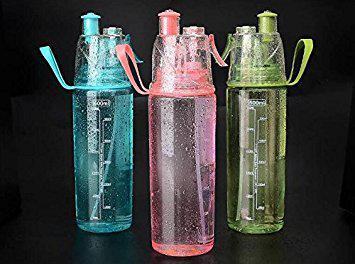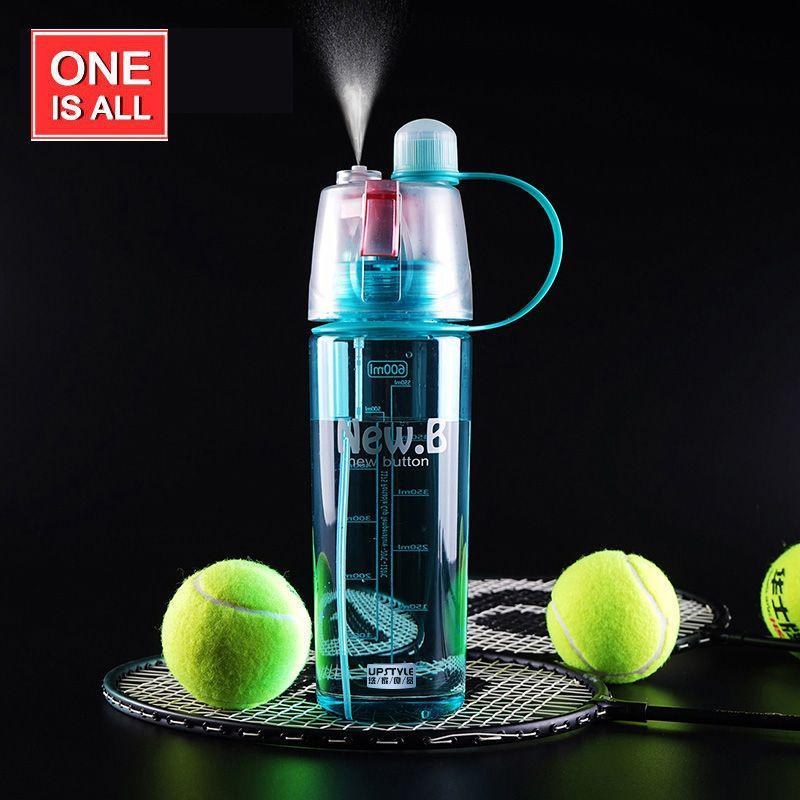The first image is the image on the left, the second image is the image on the right. Analyze the images presented: Is the assertion "The left image has three water bottles" valid? Answer yes or no. Yes. 